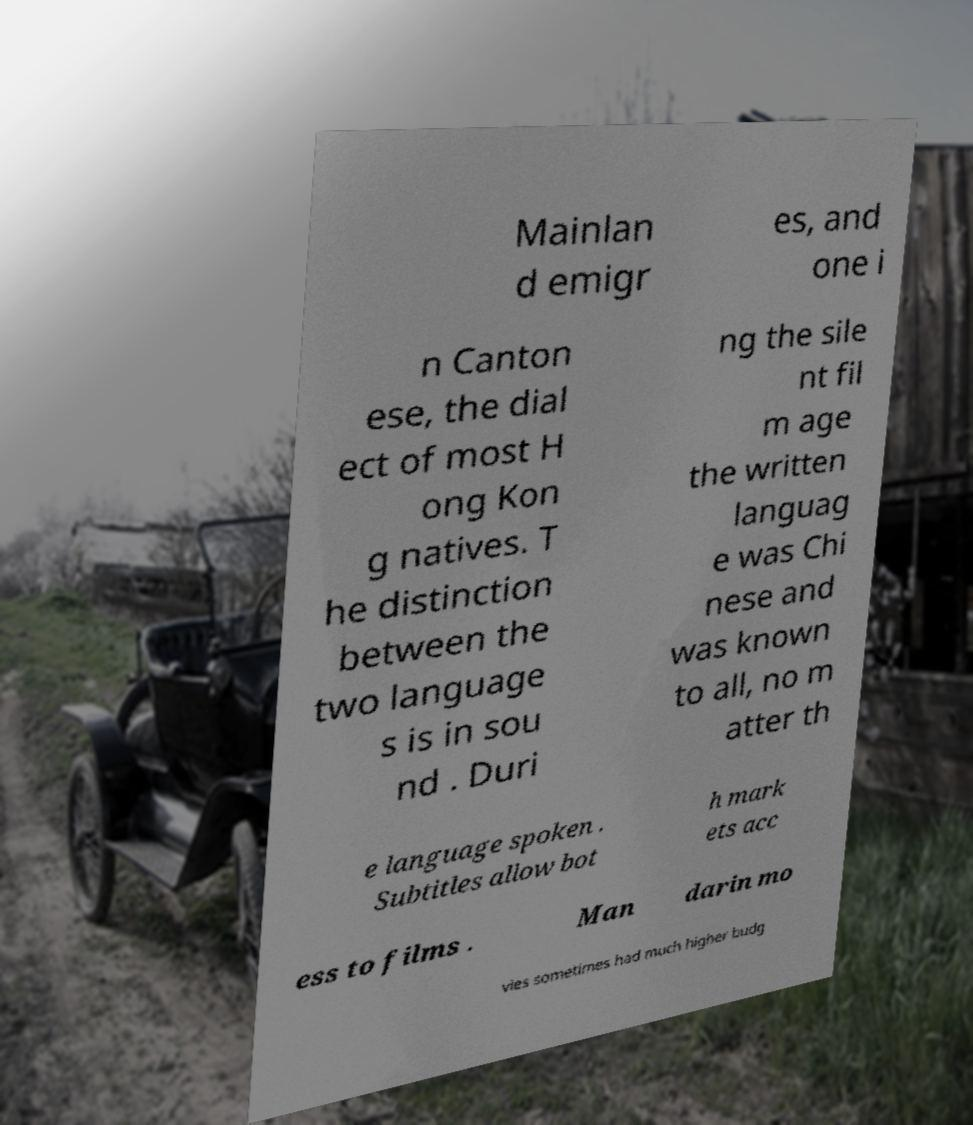Please identify and transcribe the text found in this image. Mainlan d emigr es, and one i n Canton ese, the dial ect of most H ong Kon g natives. T he distinction between the two language s is in sou nd . Duri ng the sile nt fil m age the written languag e was Chi nese and was known to all, no m atter th e language spoken . Subtitles allow bot h mark ets acc ess to films . Man darin mo vies sometimes had much higher budg 